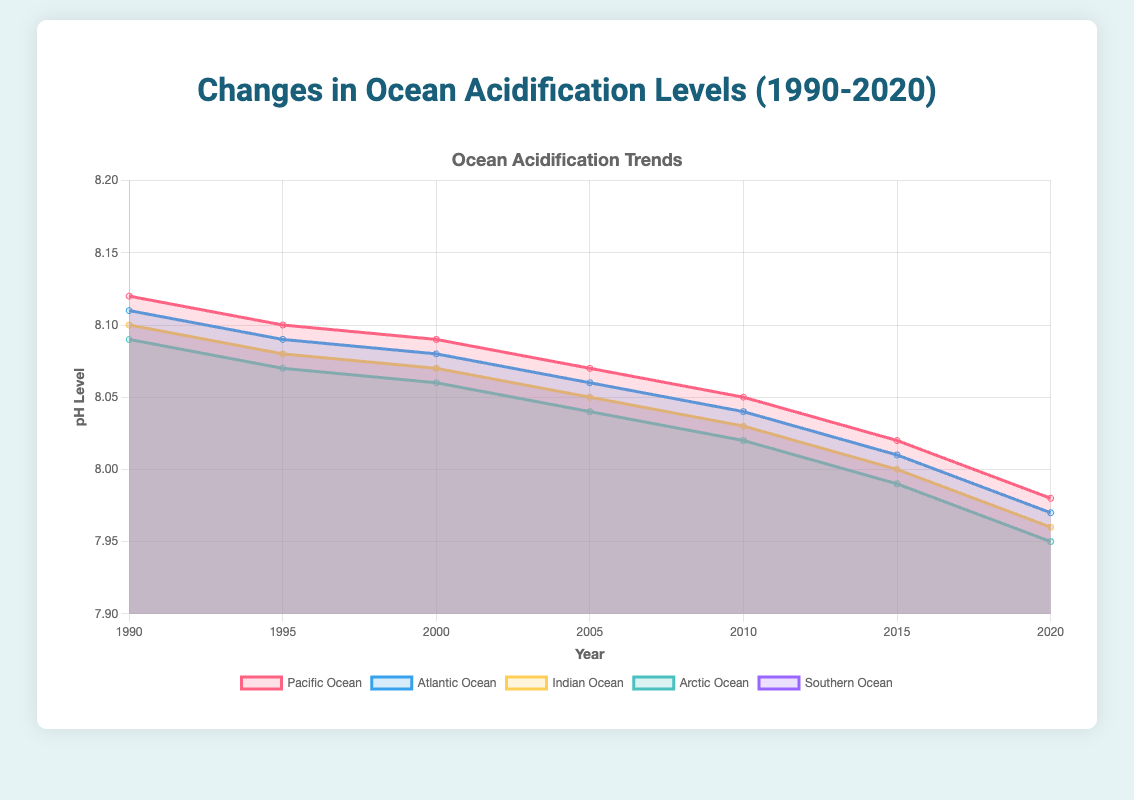What's the title of the figure? The title of the figure is clearly indicated at the top and reads "Changes in Ocean Acidification Levels (1990-2020)".
Answer: Changes in Ocean Acidification Levels (1990-2020) How many years are displayed in the figure? The x-axis of the figure shows the years labeled as 1990, 1995, 2000, 2005, 2010, 2015, and 2020. By counting these labels, we get a total of 7 years.
Answer: 7 What is the pH level of the Pacific Ocean in 2015? By looking at the specific data point on the line representing the Pacific Ocean for the year 2015, the pH level is 8.02.
Answer: 8.02 Which ocean has the lowest pH level in 2020? Observing the data points for the year 2020 across all ocean lines, the Arctic Ocean has the lowest pH level at 7.95.
Answer: Arctic Ocean Compare the pH levels of the Atlantic and Indian Oceans in 2000. Which one was higher? Checking the data points for the year 2000, the pH level of the Atlantic Ocean is 8.08, and the Indian Ocean is 8.07. Therefore, the Atlantic Ocean had a higher pH level in 2000.
Answer: Atlantic Ocean Among all oceans, which one experienced the greatest decrease in pH level from 1990 to 2020? To determine the greatest decrease, we need to compare the difference between 1990 and 2020 pH levels for each ocean. The Arctic Ocean had the steepest decline from 8.09 to 7.95, a difference of 0.14, which is the greatest.
Answer: Arctic Ocean What is the average pH level of the Southern Ocean across all years? Summing the pH levels of the Southern Ocean for all years (8.10, 8.08, 8.07, 8.05, 8.03, 8.00, 7.96) gives 56.29. Dividing this by the 7 years results in an average pH level of 8.04.
Answer: 8.04 Which ocean's pH levels intersect the most with those of the Atlantic Ocean over the period? By comparing the curves visually, the pH levels of the Indian Ocean frequently intersect with those of the Atlantic Ocean across various years, indicating similar acidification trends.
Answer: Indian Ocean What is the range of pH levels for the Indian Ocean from 1990 to 2020? The highest pH level for the Indian Ocean is in 1990 at 8.10, and the lowest is in 2020 at 7.96. The range is calculated as 8.10 - 7.96 = 0.14.
Answer: 0.14 